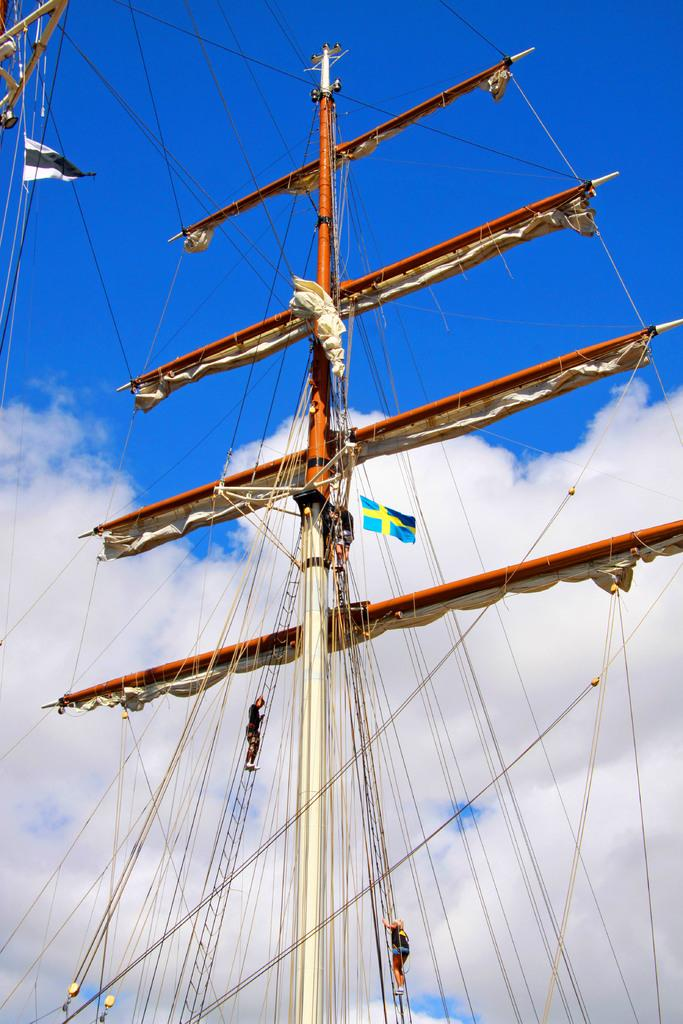What is the main object in the image? There is a ship pole in the image. What are the two people doing in the image? Two people are climbing the ship pole. What can be seen flying in the image? There is a flag in the image. What type of material is visible in the image? There is cloth visible in the image. What else is present in the image besides the ship pole and people? Wires are present in the image. What is the color of the sky in the image? The sky is blue and white in color. How many cream-filled chairs can be seen in the image? There are no cream-filled chairs present in the image. What type of judge is depicted in the image? There is no judge depicted in the image. 